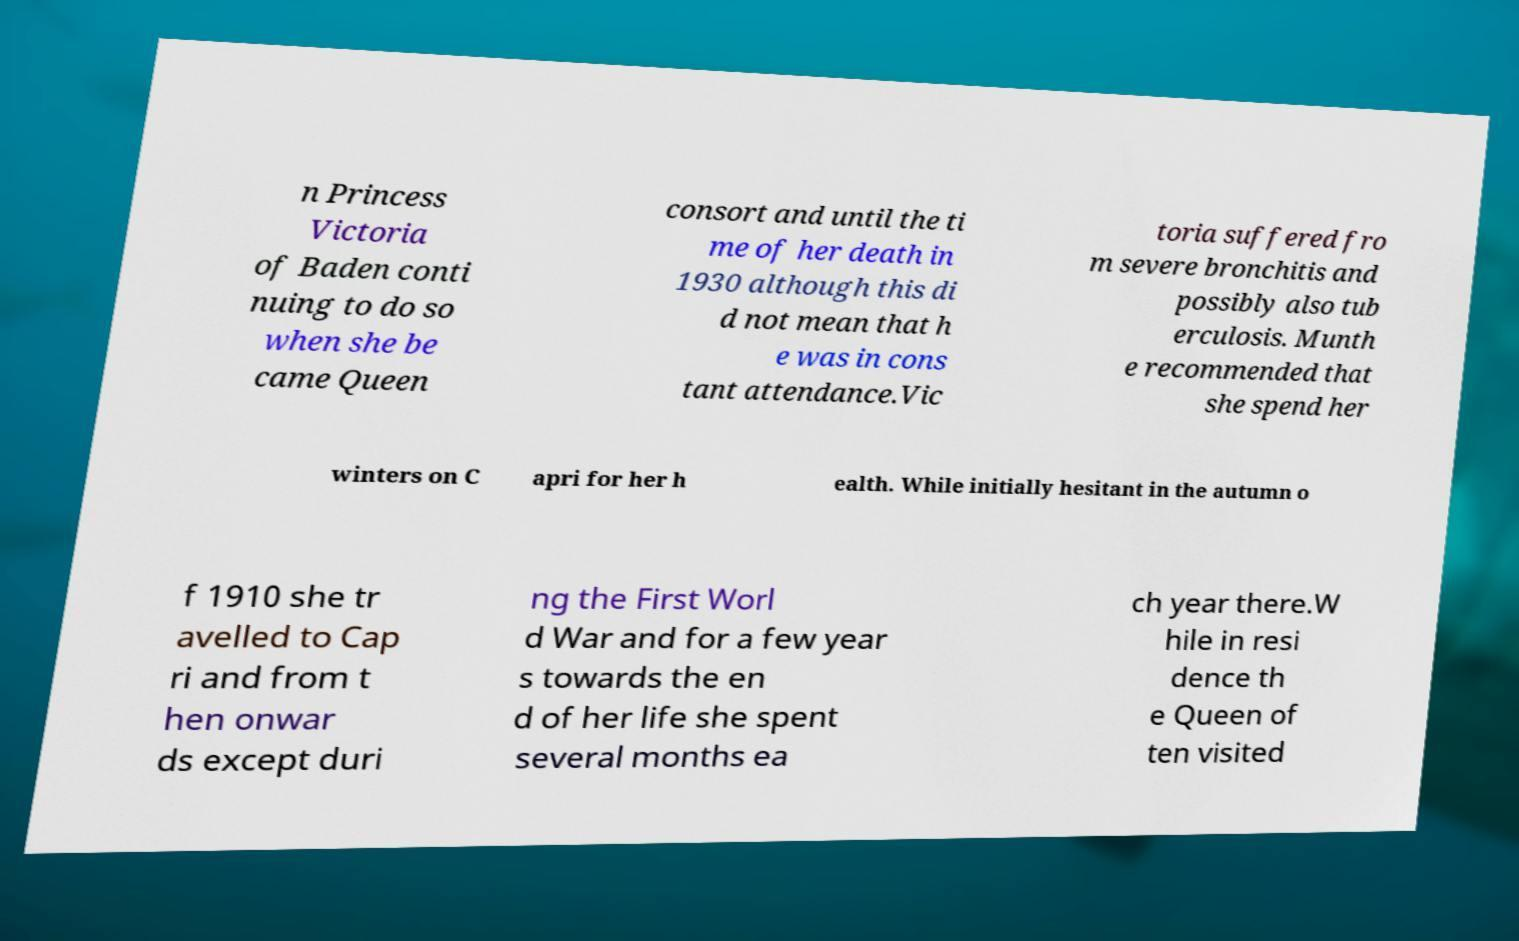I need the written content from this picture converted into text. Can you do that? n Princess Victoria of Baden conti nuing to do so when she be came Queen consort and until the ti me of her death in 1930 although this di d not mean that h e was in cons tant attendance.Vic toria suffered fro m severe bronchitis and possibly also tub erculosis. Munth e recommended that she spend her winters on C apri for her h ealth. While initially hesitant in the autumn o f 1910 she tr avelled to Cap ri and from t hen onwar ds except duri ng the First Worl d War and for a few year s towards the en d of her life she spent several months ea ch year there.W hile in resi dence th e Queen of ten visited 